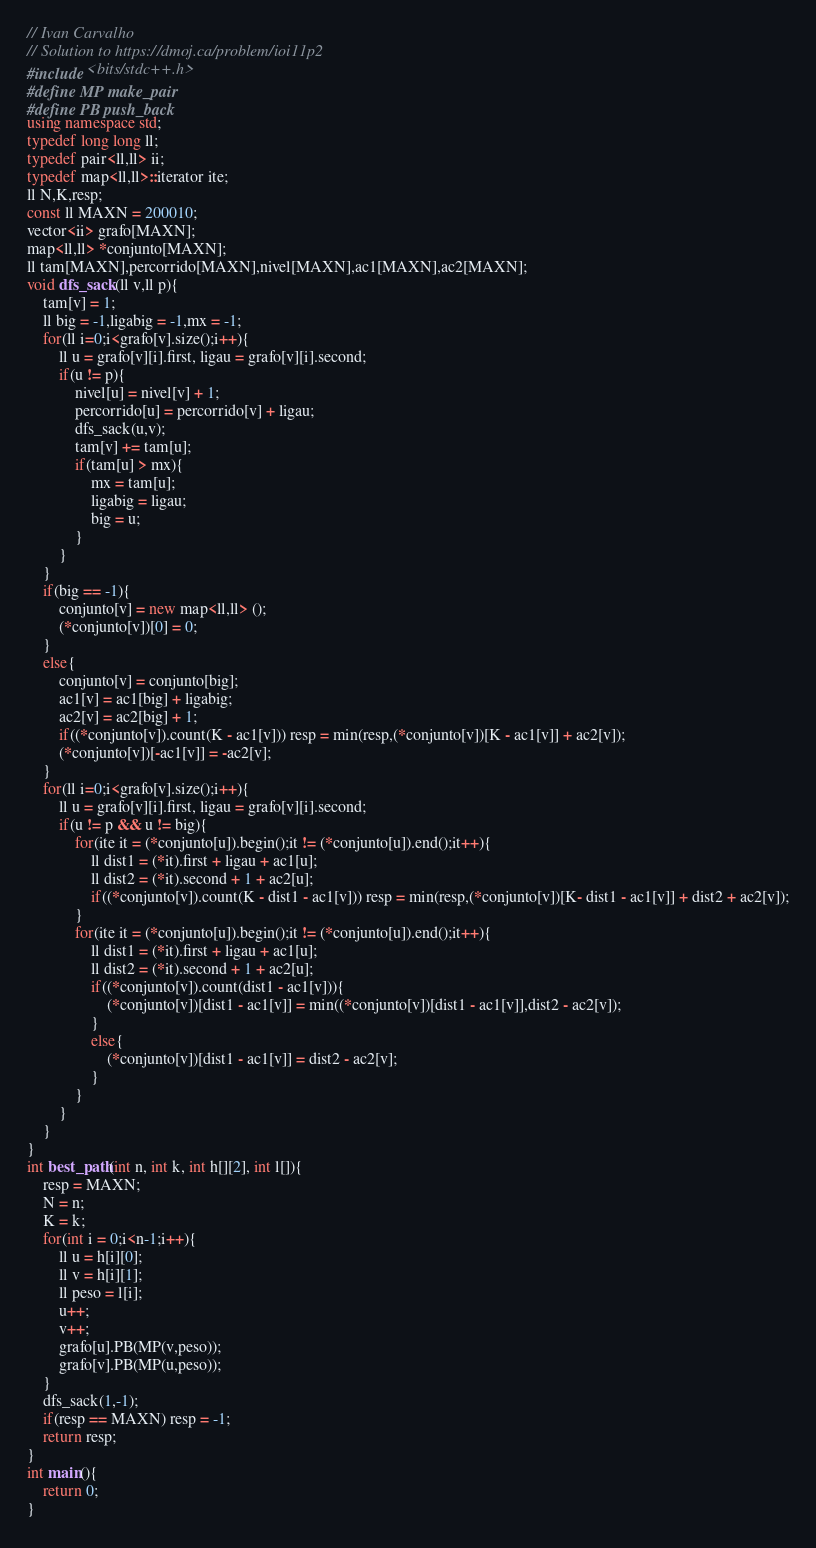<code> <loc_0><loc_0><loc_500><loc_500><_C++_>// Ivan Carvalho
// Solution to https://dmoj.ca/problem/ioi11p2
#include <bits/stdc++.h>
#define MP make_pair
#define PB push_back
using namespace std;
typedef long long ll;
typedef pair<ll,ll> ii;
typedef map<ll,ll>::iterator ite;
ll N,K,resp;
const ll MAXN = 200010;
vector<ii> grafo[MAXN];
map<ll,ll> *conjunto[MAXN];
ll tam[MAXN],percorrido[MAXN],nivel[MAXN],ac1[MAXN],ac2[MAXN];
void dfs_sack(ll v,ll p){
	tam[v] = 1;
	ll big = -1,ligabig = -1,mx = -1;
	for(ll i=0;i<grafo[v].size();i++){
		ll u = grafo[v][i].first, ligau = grafo[v][i].second;
		if(u != p){
			nivel[u] = nivel[v] + 1;
			percorrido[u] = percorrido[v] + ligau;
			dfs_sack(u,v);
			tam[v] += tam[u];
			if(tam[u] > mx){
				mx = tam[u];
				ligabig = ligau;
				big = u;
			}
		}
	}
	if(big == -1){
		conjunto[v] = new map<ll,ll> ();
		(*conjunto[v])[0] = 0;
	}
	else{
		conjunto[v] = conjunto[big];
		ac1[v] = ac1[big] + ligabig;
		ac2[v] = ac2[big] + 1;
		if((*conjunto[v]).count(K - ac1[v])) resp = min(resp,(*conjunto[v])[K - ac1[v]] + ac2[v]);
		(*conjunto[v])[-ac1[v]] = -ac2[v];
	}
	for(ll i=0;i<grafo[v].size();i++){
		ll u = grafo[v][i].first, ligau = grafo[v][i].second;
		if(u != p && u != big){
			for(ite it = (*conjunto[u]).begin();it != (*conjunto[u]).end();it++){
				ll dist1 = (*it).first + ligau + ac1[u];
				ll dist2 = (*it).second + 1 + ac2[u];
				if((*conjunto[v]).count(K - dist1 - ac1[v])) resp = min(resp,(*conjunto[v])[K- dist1 - ac1[v]] + dist2 + ac2[v]);
			}
			for(ite it = (*conjunto[u]).begin();it != (*conjunto[u]).end();it++){
				ll dist1 = (*it).first + ligau + ac1[u];
				ll dist2 = (*it).second + 1 + ac2[u];
				if((*conjunto[v]).count(dist1 - ac1[v])){
					(*conjunto[v])[dist1 - ac1[v]] = min((*conjunto[v])[dist1 - ac1[v]],dist2 - ac2[v]);
				}
				else{
					(*conjunto[v])[dist1 - ac1[v]] = dist2 - ac2[v];
				}
			}
		}
	}
}
int best_path(int n, int k, int h[][2], int l[]){
	resp = MAXN;
	N = n;
	K = k;
	for(int i = 0;i<n-1;i++){
		ll u = h[i][0];
		ll v = h[i][1];
		ll peso = l[i]; 
		u++;
		v++;
		grafo[u].PB(MP(v,peso));
		grafo[v].PB(MP(u,peso));
	}
	dfs_sack(1,-1);
	if(resp == MAXN) resp = -1;
	return resp;
}
int main(){
	return 0;
}
</code> 